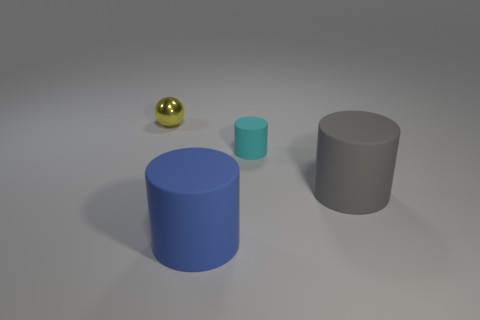Is the big cylinder that is to the left of the small rubber cylinder made of the same material as the large cylinder that is on the right side of the blue matte thing?
Offer a terse response. Yes. There is another large thing that is made of the same material as the big blue thing; what is its color?
Your response must be concise. Gray. Are there more cylinders to the left of the big blue object than cyan things that are on the left side of the yellow metallic sphere?
Keep it short and to the point. No. Are there any small cyan matte cylinders?
Your answer should be very brief. Yes. What number of objects are cylinders or gray things?
Your response must be concise. 3. Is there a tiny metal object of the same color as the tiny ball?
Your answer should be compact. No. There is a rubber cylinder that is in front of the big gray rubber object; how many gray matte cylinders are right of it?
Provide a succinct answer. 1. Is the number of purple spheres greater than the number of big gray objects?
Ensure brevity in your answer.  No. Is the material of the large gray thing the same as the tiny cyan cylinder?
Provide a short and direct response. Yes. Is the number of big gray matte things on the left side of the big blue cylinder the same as the number of yellow spheres?
Ensure brevity in your answer.  No. 